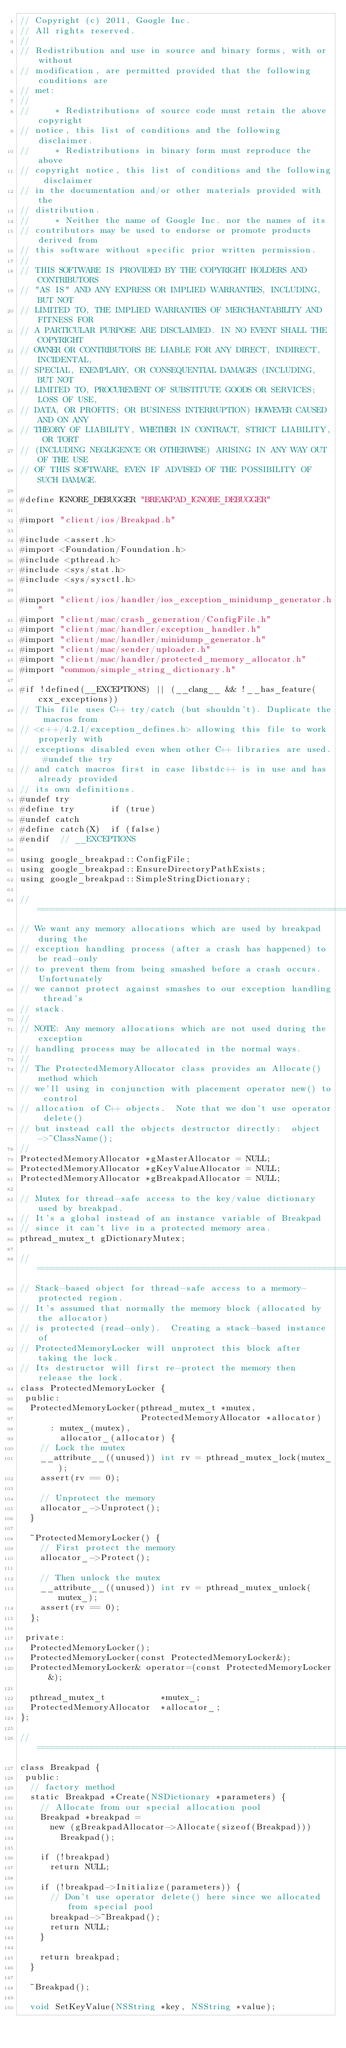Convert code to text. <code><loc_0><loc_0><loc_500><loc_500><_ObjectiveC_>// Copyright (c) 2011, Google Inc.
// All rights reserved.
//
// Redistribution and use in source and binary forms, with or without
// modification, are permitted provided that the following conditions are
// met:
//
//     * Redistributions of source code must retain the above copyright
// notice, this list of conditions and the following disclaimer.
//     * Redistributions in binary form must reproduce the above
// copyright notice, this list of conditions and the following disclaimer
// in the documentation and/or other materials provided with the
// distribution.
//     * Neither the name of Google Inc. nor the names of its
// contributors may be used to endorse or promote products derived from
// this software without specific prior written permission.
//
// THIS SOFTWARE IS PROVIDED BY THE COPYRIGHT HOLDERS AND CONTRIBUTORS
// "AS IS" AND ANY EXPRESS OR IMPLIED WARRANTIES, INCLUDING, BUT NOT
// LIMITED TO, THE IMPLIED WARRANTIES OF MERCHANTABILITY AND FITNESS FOR
// A PARTICULAR PURPOSE ARE DISCLAIMED. IN NO EVENT SHALL THE COPYRIGHT
// OWNER OR CONTRIBUTORS BE LIABLE FOR ANY DIRECT, INDIRECT, INCIDENTAL,
// SPECIAL, EXEMPLARY, OR CONSEQUENTIAL DAMAGES (INCLUDING, BUT NOT
// LIMITED TO, PROCUREMENT OF SUBSTITUTE GOODS OR SERVICES; LOSS OF USE,
// DATA, OR PROFITS; OR BUSINESS INTERRUPTION) HOWEVER CAUSED AND ON ANY
// THEORY OF LIABILITY, WHETHER IN CONTRACT, STRICT LIABILITY, OR TORT
// (INCLUDING NEGLIGENCE OR OTHERWISE) ARISING IN ANY WAY OUT OF THE USE
// OF THIS SOFTWARE, EVEN IF ADVISED OF THE POSSIBILITY OF SUCH DAMAGE.

#define IGNORE_DEBUGGER "BREAKPAD_IGNORE_DEBUGGER"

#import "client/ios/Breakpad.h"

#include <assert.h>
#import <Foundation/Foundation.h>
#include <pthread.h>
#include <sys/stat.h>
#include <sys/sysctl.h>

#import "client/ios/handler/ios_exception_minidump_generator.h"
#import "client/mac/crash_generation/ConfigFile.h"
#import "client/mac/handler/exception_handler.h"
#import "client/mac/handler/minidump_generator.h"
#import "client/mac/sender/uploader.h"
#import "client/mac/handler/protected_memory_allocator.h"
#import "common/simple_string_dictionary.h"

#if !defined(__EXCEPTIONS) || (__clang__ && !__has_feature(cxx_exceptions))
// This file uses C++ try/catch (but shouldn't). Duplicate the macros from
// <c++/4.2.1/exception_defines.h> allowing this file to work properly with
// exceptions disabled even when other C++ libraries are used. #undef the try
// and catch macros first in case libstdc++ is in use and has already provided
// its own definitions.
#undef try
#define try       if (true)
#undef catch
#define catch(X)  if (false)
#endif  // __EXCEPTIONS

using google_breakpad::ConfigFile;
using google_breakpad::EnsureDirectoryPathExists;
using google_breakpad::SimpleStringDictionary;

//=============================================================================
// We want any memory allocations which are used by breakpad during the
// exception handling process (after a crash has happened) to be read-only
// to prevent them from being smashed before a crash occurs.  Unfortunately
// we cannot protect against smashes to our exception handling thread's
// stack.
//
// NOTE: Any memory allocations which are not used during the exception
// handling process may be allocated in the normal ways.
//
// The ProtectedMemoryAllocator class provides an Allocate() method which
// we'll using in conjunction with placement operator new() to control
// allocation of C++ objects.  Note that we don't use operator delete()
// but instead call the objects destructor directly:  object->~ClassName();
//
ProtectedMemoryAllocator *gMasterAllocator = NULL;
ProtectedMemoryAllocator *gKeyValueAllocator = NULL;
ProtectedMemoryAllocator *gBreakpadAllocator = NULL;

// Mutex for thread-safe access to the key/value dictionary used by breakpad.
// It's a global instead of an instance variable of Breakpad
// since it can't live in a protected memory area.
pthread_mutex_t gDictionaryMutex;

//=============================================================================
// Stack-based object for thread-safe access to a memory-protected region.
// It's assumed that normally the memory block (allocated by the allocator)
// is protected (read-only).  Creating a stack-based instance of
// ProtectedMemoryLocker will unprotect this block after taking the lock.
// Its destructor will first re-protect the memory then release the lock.
class ProtectedMemoryLocker {
 public:
  ProtectedMemoryLocker(pthread_mutex_t *mutex,
                        ProtectedMemoryAllocator *allocator)
      : mutex_(mutex),
        allocator_(allocator) {
    // Lock the mutex
    __attribute__((unused)) int rv = pthread_mutex_lock(mutex_);
    assert(rv == 0);

    // Unprotect the memory
    allocator_->Unprotect();
  }

  ~ProtectedMemoryLocker() {
    // First protect the memory
    allocator_->Protect();

    // Then unlock the mutex
    __attribute__((unused)) int rv = pthread_mutex_unlock(mutex_);
    assert(rv == 0);
  };

 private:
  ProtectedMemoryLocker();
  ProtectedMemoryLocker(const ProtectedMemoryLocker&);
  ProtectedMemoryLocker& operator=(const ProtectedMemoryLocker&);

  pthread_mutex_t           *mutex_;
  ProtectedMemoryAllocator  *allocator_;
};

//=============================================================================
class Breakpad {
 public:
  // factory method
  static Breakpad *Create(NSDictionary *parameters) {
    // Allocate from our special allocation pool
    Breakpad *breakpad =
      new (gBreakpadAllocator->Allocate(sizeof(Breakpad)))
        Breakpad();

    if (!breakpad)
      return NULL;

    if (!breakpad->Initialize(parameters)) {
      // Don't use operator delete() here since we allocated from special pool
      breakpad->~Breakpad();
      return NULL;
    }

    return breakpad;
  }

  ~Breakpad();

  void SetKeyValue(NSString *key, NSString *value);</code> 